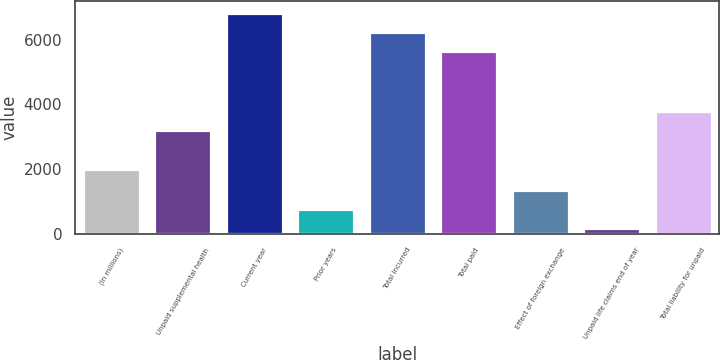<chart> <loc_0><loc_0><loc_500><loc_500><bar_chart><fcel>(In millions)<fcel>Unpaid supplemental health<fcel>Current year<fcel>Prior years<fcel>Total incurred<fcel>Total paid<fcel>Effect of foreign exchange<fcel>Unpaid life claims end of year<fcel>Total liability for unpaid<nl><fcel>2008<fcel>3201.6<fcel>6846.6<fcel>755.8<fcel>6249.8<fcel>5653<fcel>1352.6<fcel>159<fcel>3798.4<nl></chart> 